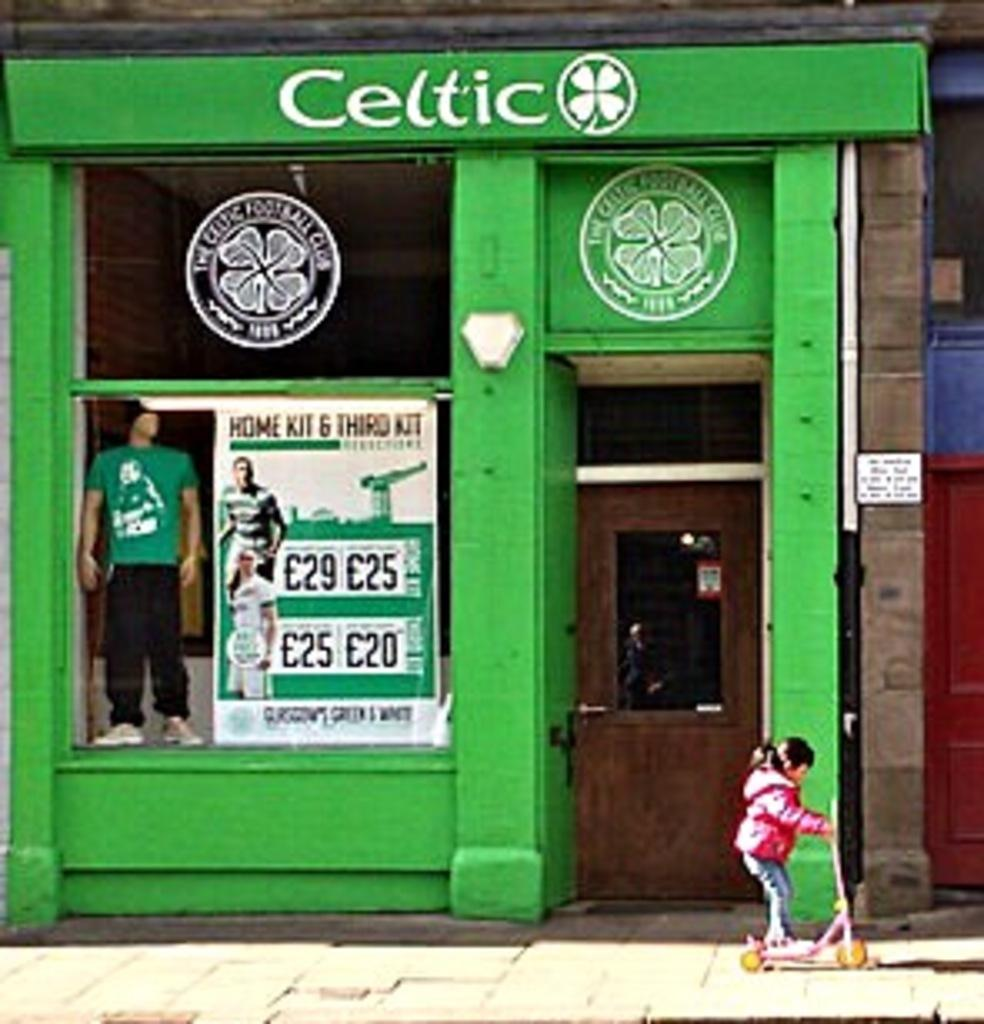Provide a one-sentence caption for the provided image. A bright green storefront for the Celtic football club. 